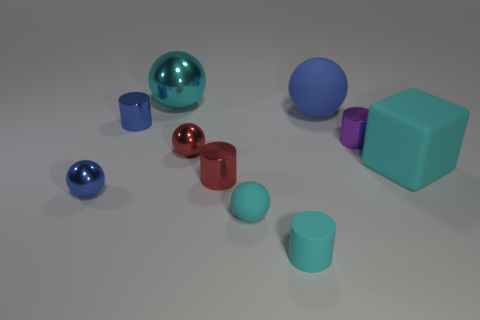There is a large metallic object that is behind the small blue metal sphere; how many blue spheres are on the left side of it?
Make the answer very short. 1. How many things are either small blue metal objects or small matte cylinders?
Offer a very short reply. 3. Do the large metallic thing and the big blue rubber thing have the same shape?
Keep it short and to the point. Yes. What is the big blue ball made of?
Keep it short and to the point. Rubber. What number of small shiny cylinders are in front of the purple cylinder and behind the tiny purple metal thing?
Give a very brief answer. 0. Is the size of the cyan rubber cube the same as the purple cylinder?
Offer a very short reply. No. Is the size of the blue metal thing in front of the purple cylinder the same as the red metal cylinder?
Your answer should be compact. Yes. The large object that is on the left side of the rubber cylinder is what color?
Offer a very short reply. Cyan. What number of cyan matte objects are there?
Your response must be concise. 3. There is a small red object that is the same material as the tiny red sphere; what shape is it?
Offer a terse response. Cylinder. 